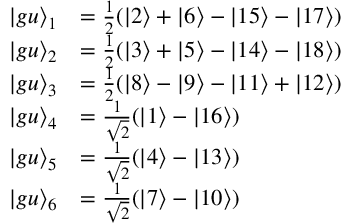Convert formula to latex. <formula><loc_0><loc_0><loc_500><loc_500>\begin{array} { r l } { | g u \rangle _ { 1 } } & { = \frac { 1 } { 2 } ( | 2 \rangle + | 6 \rangle - | 1 5 \rangle - | 1 7 \rangle ) } \\ { | g u \rangle _ { 2 } } & { = \frac { 1 } { 2 } ( | 3 \rangle + | 5 \rangle - | 1 4 \rangle - | 1 8 \rangle ) } \\ { | g u \rangle _ { 3 } } & { = \frac { 1 } { 2 } ( | 8 \rangle - | 9 \rangle - | 1 1 \rangle + | 1 2 \rangle ) } \\ { | g u \rangle _ { 4 } } & { = \frac { 1 } { \sqrt { 2 } } ( | 1 \rangle - | 1 6 \rangle ) } \\ { | g u \rangle _ { 5 } } & { = \frac { 1 } { \sqrt { 2 } } ( | 4 \rangle - | 1 3 \rangle ) } \\ { | g u \rangle _ { 6 } } & { = \frac { 1 } { \sqrt { 2 } } ( | 7 \rangle - | 1 0 \rangle ) } \end{array}</formula> 